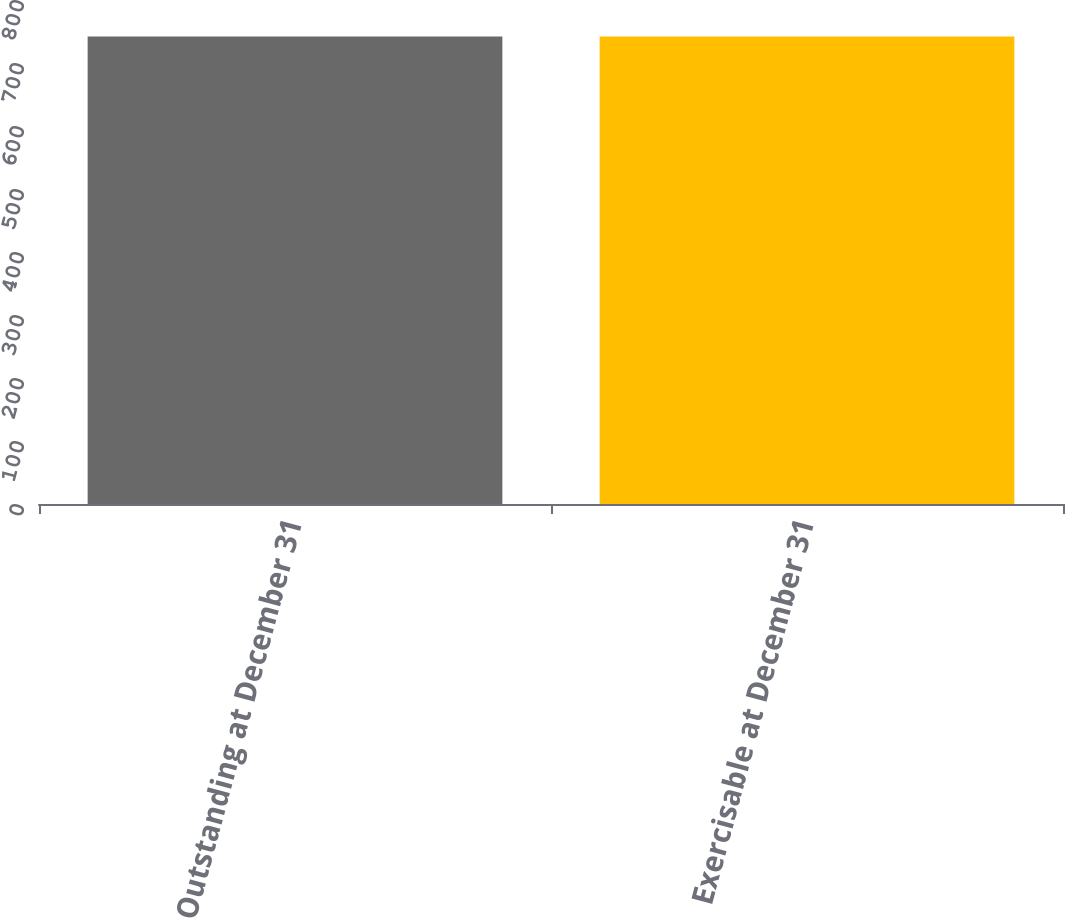Convert chart to OTSL. <chart><loc_0><loc_0><loc_500><loc_500><bar_chart><fcel>Outstanding at December 31<fcel>Exercisable at December 31<nl><fcel>742<fcel>742.1<nl></chart> 